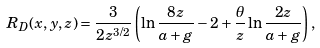Convert formula to latex. <formula><loc_0><loc_0><loc_500><loc_500>R _ { D } ( x , y , z ) = \frac { 3 } { 2 z ^ { 3 / 2 } } \left ( \ln \frac { 8 z } { a + g } - 2 + \frac { \theta } { z } \ln \frac { 2 z } { a + g } \right ) ,</formula> 